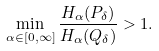Convert formula to latex. <formula><loc_0><loc_0><loc_500><loc_500>\min _ { \alpha \in [ 0 , \infty ] } \frac { H _ { \alpha } ( P _ { \delta } ) } { H _ { \alpha } ( Q _ { \delta } ) } > 1 .</formula> 